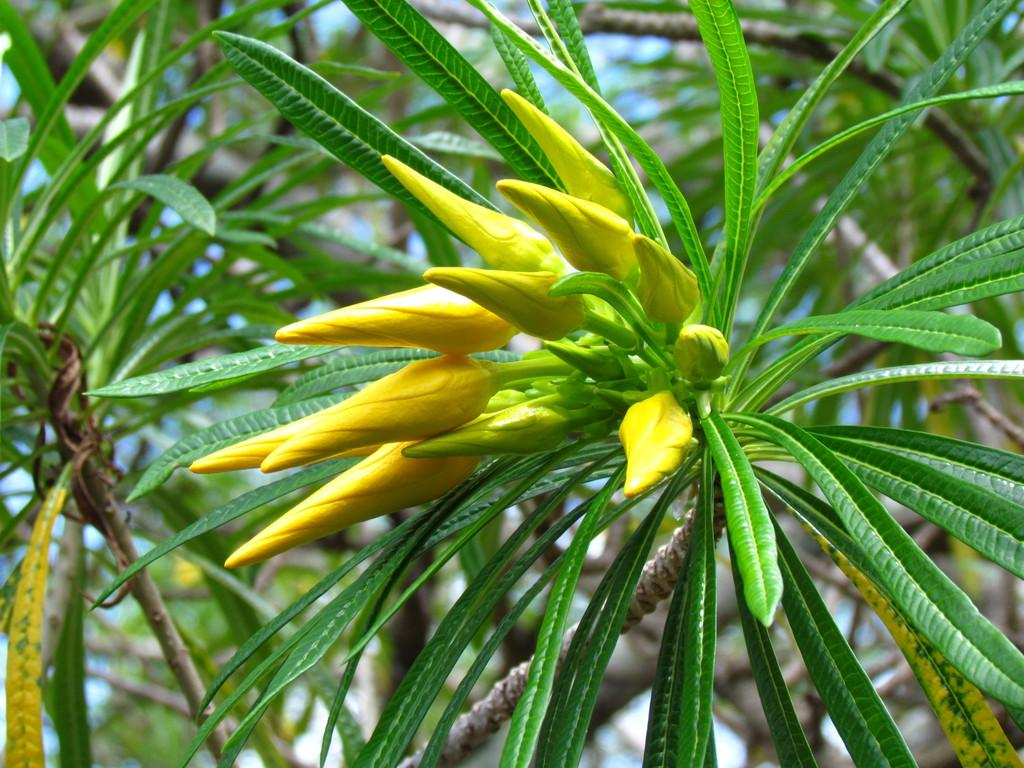What type of plant material can be seen in the image? There are leaves and buds in the image. Can you describe the stage of growth of the plant material? The presence of buds suggests that the plant material is in the early stages of growth. What type of badge can be seen hanging from the leaves in the image? There is no badge present in the image; it only features leaves and buds. What season is depicted in the image, considering the presence of chalk? There is no mention of chalk in the image, and the presence of leaves and buds suggests it could be spring or summer, but not a specific season. 